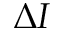Convert formula to latex. <formula><loc_0><loc_0><loc_500><loc_500>\Delta I</formula> 